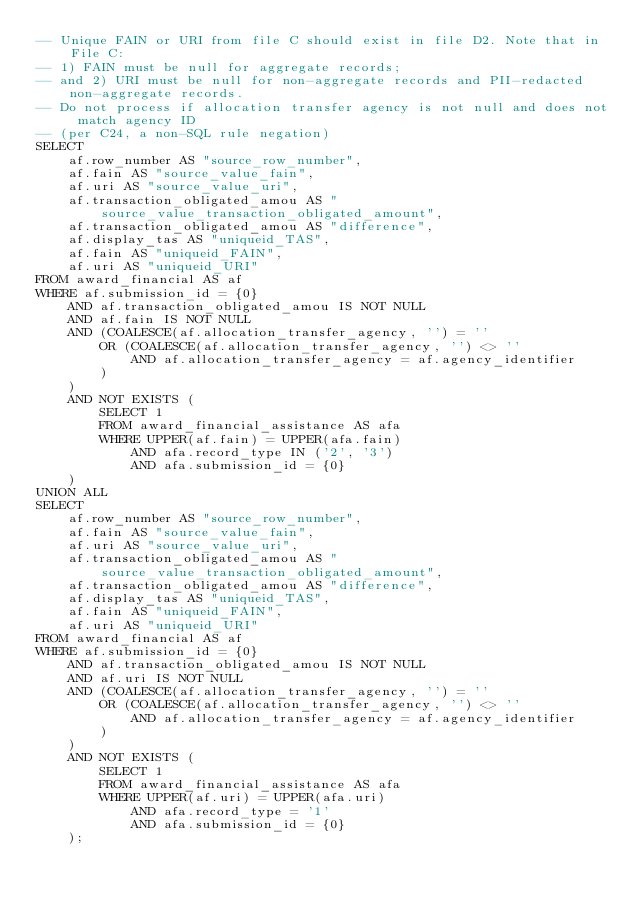<code> <loc_0><loc_0><loc_500><loc_500><_SQL_>-- Unique FAIN or URI from file C should exist in file D2. Note that in File C:
-- 1) FAIN must be null for aggregate records;
-- and 2) URI must be null for non-aggregate records and PII-redacted non-aggregate records.
-- Do not process if allocation transfer agency is not null and does not match agency ID
-- (per C24, a non-SQL rule negation)
SELECT
    af.row_number AS "source_row_number",
    af.fain AS "source_value_fain",
    af.uri AS "source_value_uri",
    af.transaction_obligated_amou AS "source_value_transaction_obligated_amount",
    af.transaction_obligated_amou AS "difference",
    af.display_tas AS "uniqueid_TAS",
    af.fain AS "uniqueid_FAIN",
    af.uri AS "uniqueid_URI"
FROM award_financial AS af
WHERE af.submission_id = {0}
    AND af.transaction_obligated_amou IS NOT NULL
    AND af.fain IS NOT NULL
    AND (COALESCE(af.allocation_transfer_agency, '') = ''
        OR (COALESCE(af.allocation_transfer_agency, '') <> ''
            AND af.allocation_transfer_agency = af.agency_identifier
        )
    )
    AND NOT EXISTS (
        SELECT 1
        FROM award_financial_assistance AS afa
        WHERE UPPER(af.fain) = UPPER(afa.fain)
            AND afa.record_type IN ('2', '3')
            AND afa.submission_id = {0}
    )
UNION ALL
SELECT
    af.row_number AS "source_row_number",
    af.fain AS "source_value_fain",
    af.uri AS "source_value_uri",
    af.transaction_obligated_amou AS "source_value_transaction_obligated_amount",
    af.transaction_obligated_amou AS "difference",
    af.display_tas AS "uniqueid_TAS",
    af.fain AS "uniqueid_FAIN",
    af.uri AS "uniqueid_URI"
FROM award_financial AS af
WHERE af.submission_id = {0}
    AND af.transaction_obligated_amou IS NOT NULL
    AND af.uri IS NOT NULL
    AND (COALESCE(af.allocation_transfer_agency, '') = ''
        OR (COALESCE(af.allocation_transfer_agency, '') <> ''
            AND af.allocation_transfer_agency = af.agency_identifier
        )
    )
    AND NOT EXISTS (
        SELECT 1
        FROM award_financial_assistance AS afa
        WHERE UPPER(af.uri) = UPPER(afa.uri)
            AND afa.record_type = '1'
            AND afa.submission_id = {0}
    );
</code> 